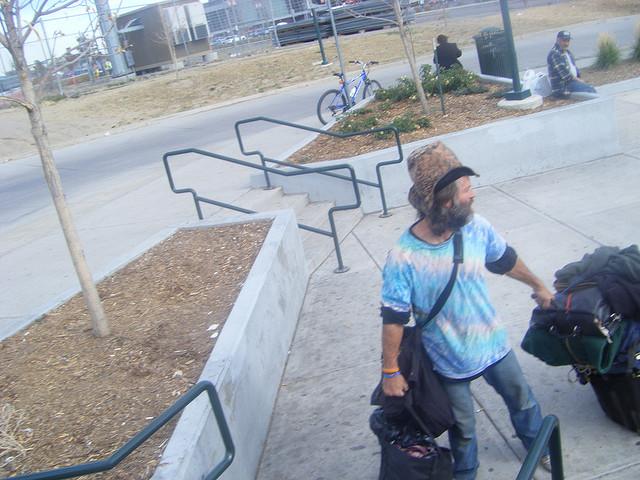What is the man tugging?
Quick response, please. Luggage. What color is the grass?
Be succinct. Brown. Is the man wearing glasses?
Quick response, please. No. How many people are in the picture?
Keep it brief. 3. How many holes on the side of the person's hat?
Answer briefly. 0. What color is the man wearing?
Concise answer only. Blue. What color are the man's pants?
Quick response, please. Blue. Who does the luggage belong to?
Answer briefly. Man. What is the man holding?
Write a very short answer. Luggage. What is he doing?
Write a very short answer. Walking. Is the man coming or going?
Give a very brief answer. Coming. How many bicycles are there?
Short answer required. 1. What color is the standing person's hood?
Quick response, please. Brown. Is he wearing a black hat?
Quick response, please. No. How many bags are sitting on the ground?
Keep it brief. 2. Is this a normal mode of transportation?
Be succinct. No. What is the man looking at?
Answer briefly. Luggage. What movie character is in the photo?
Answer briefly. None. Do all of the men have beards?
Quick response, please. Yes. What color is the man's shirt?
Concise answer only. Blue. 